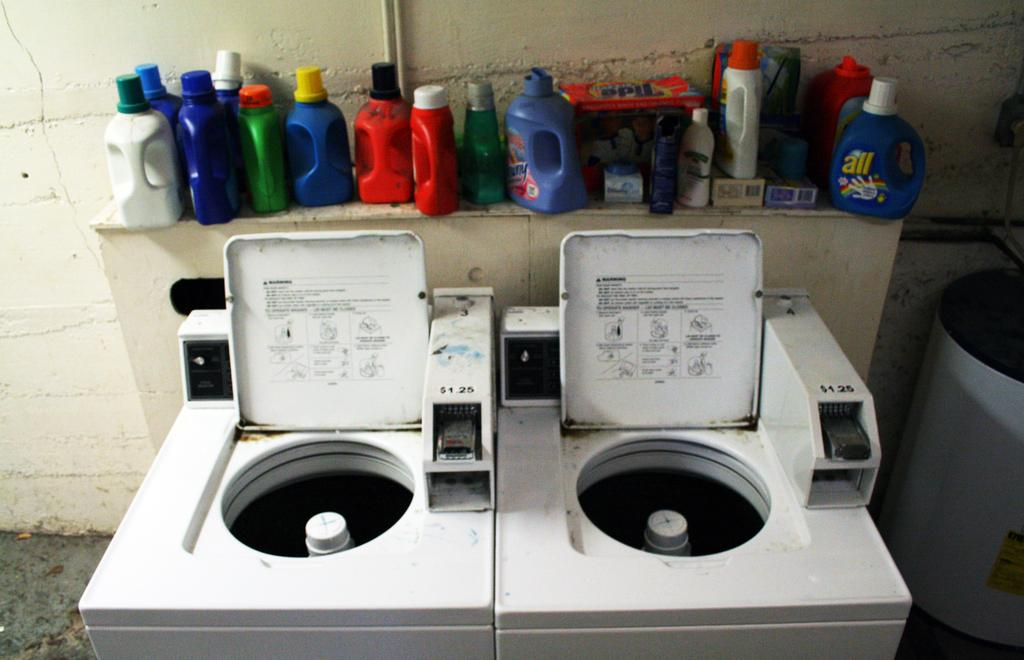What type of appliances can be seen in the image? There are two white washing machines in the image. What other items can be seen in the image besides the washing machines? There are multi-colored bottles visible in the image. What color is the wall in the image? The wall in the image is cream-colored. How many cups of coffee are being served by the cats in the image? There are no cats or cups of coffee present in the image. 